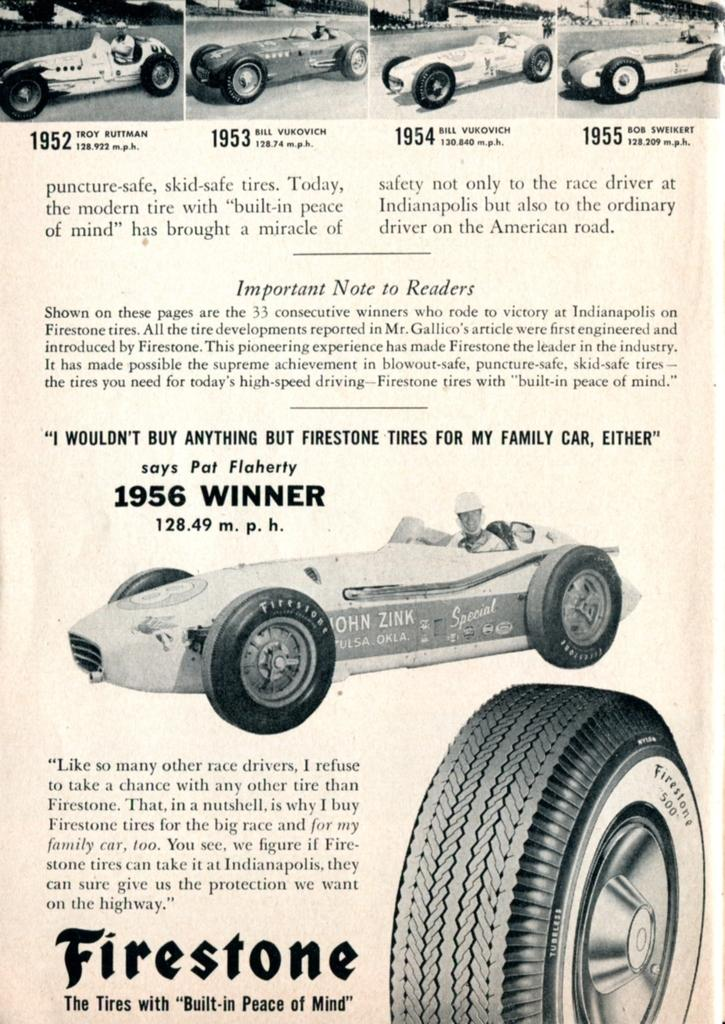What is the color scheme of the image? The image is in black and white. What object can be seen in the image besides the car? There is a paper and a tire visible in the image. What is the main subject of the image? The main subject of the image is a car. How many different car images are present in the image? There are four different car images at the top of the image. What type of stove is visible in the image? There is no stove present in the image. What is the governor doing in the image? There is no governor present in the image. 